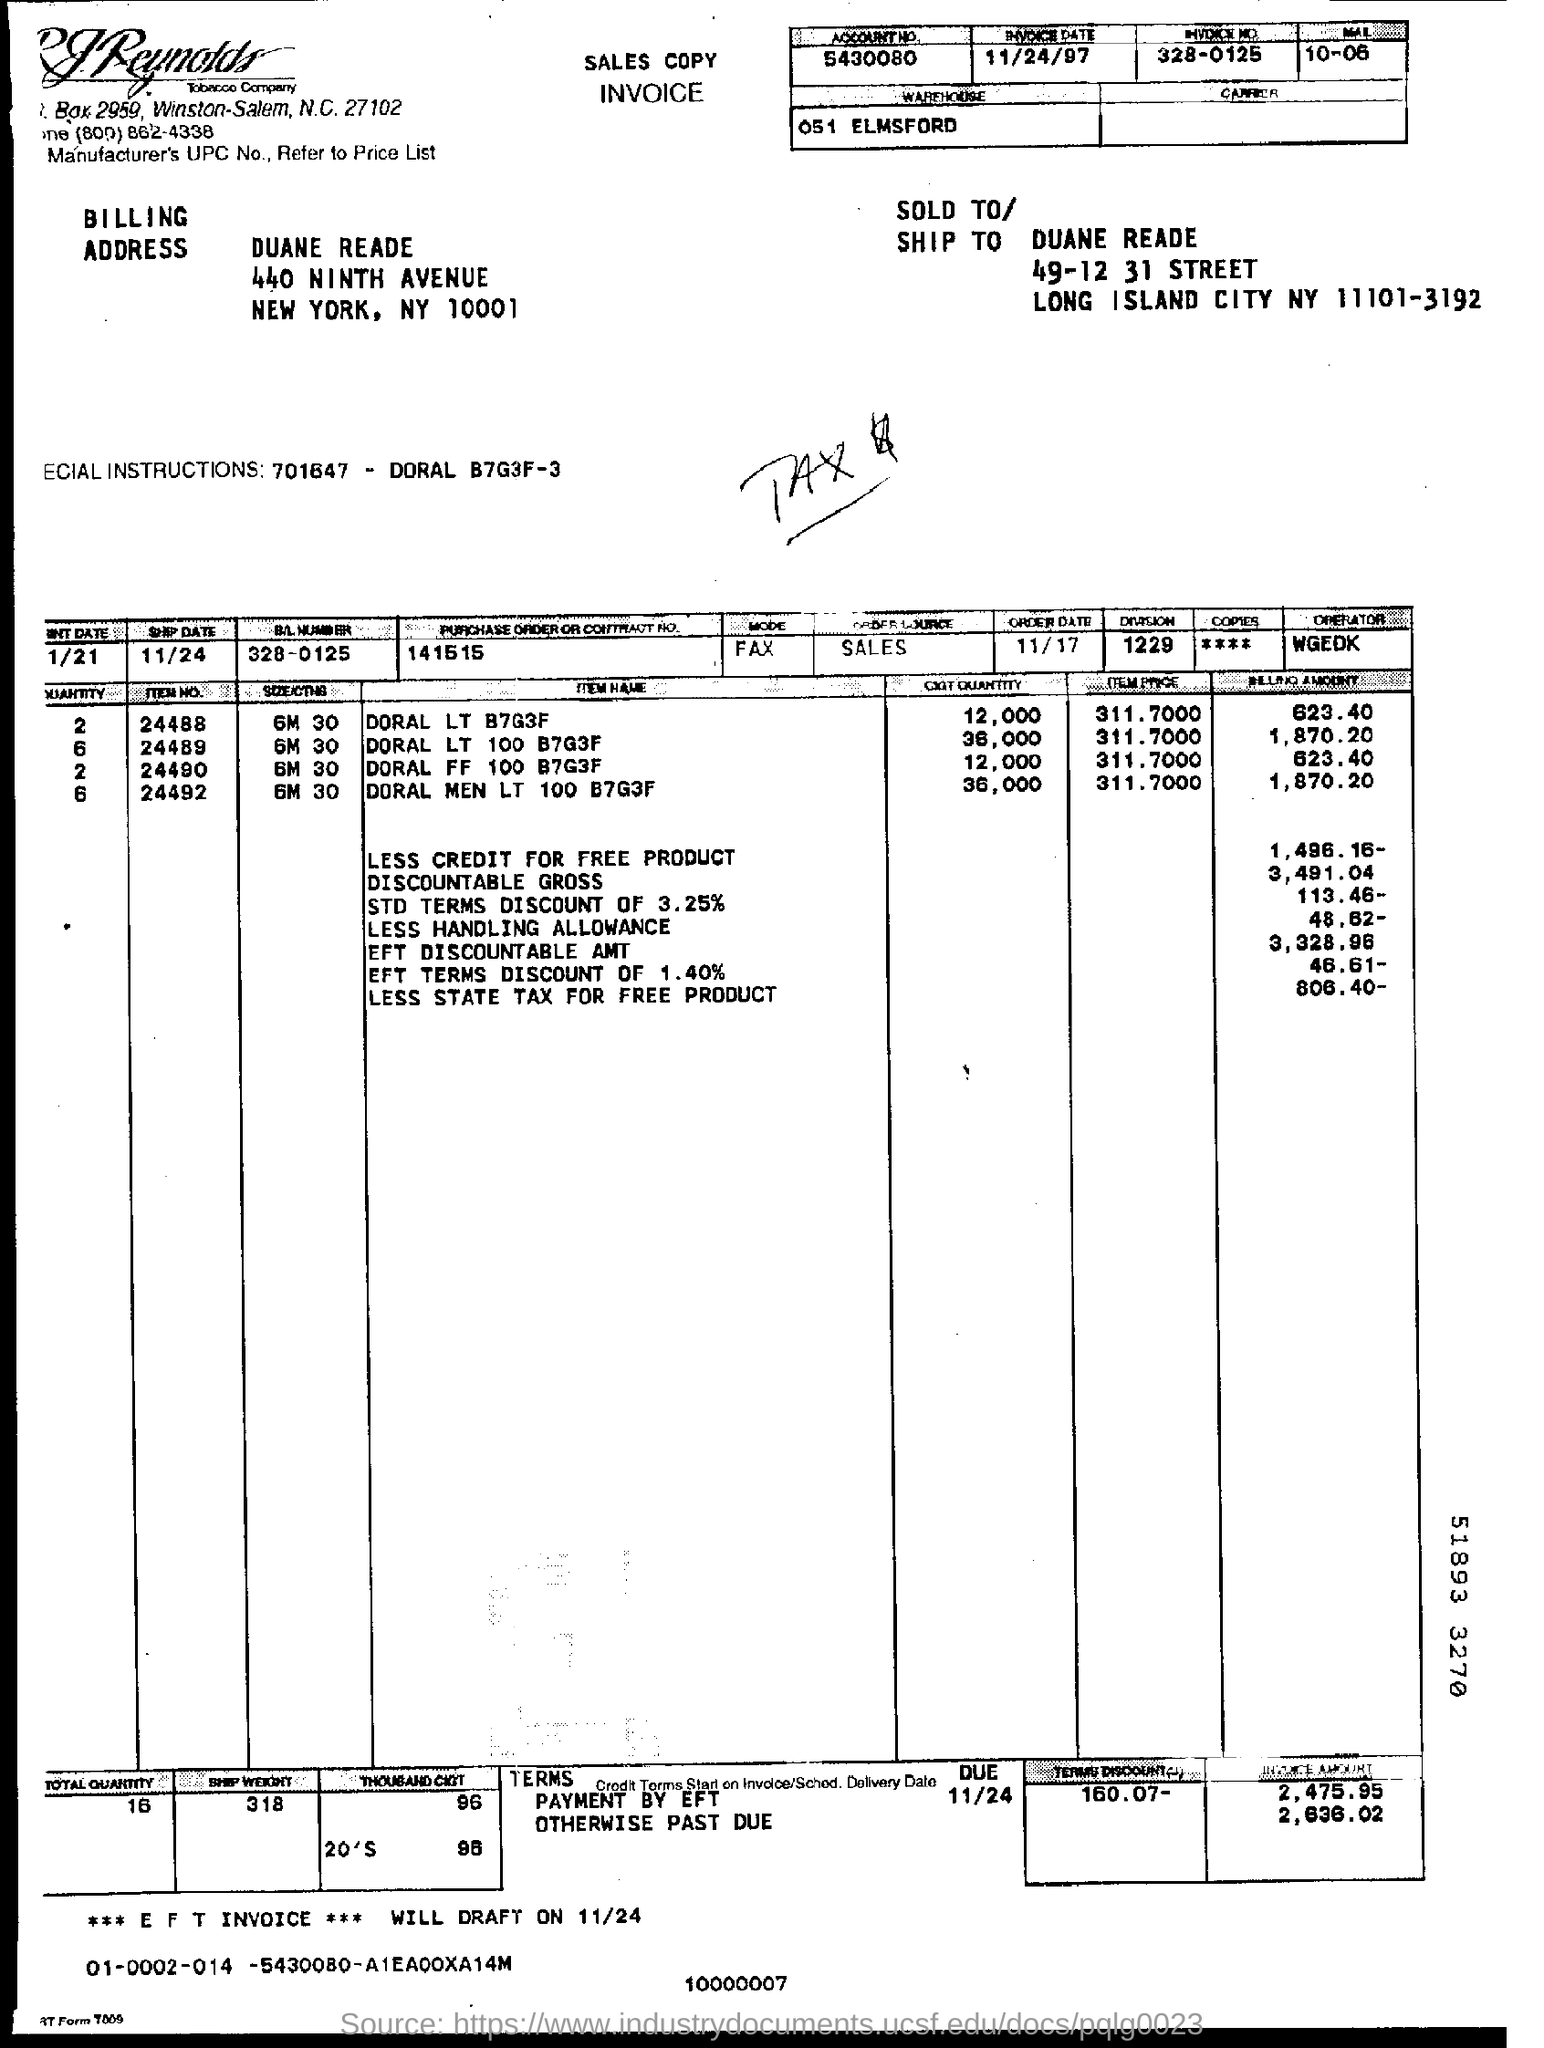Indicate a few pertinent items in this graphic. The street name mentioned in the "SOLD TO/SHIP TO" address is 49-12 31STREET. Payment of $2,475.95 by EFT within the due date is required. The billing address mentioned a ZIP code of 10001. Please mention the date provided, which is 11/24.. The Purchase Order or Contract Number provided at the top of the table is 141515. 